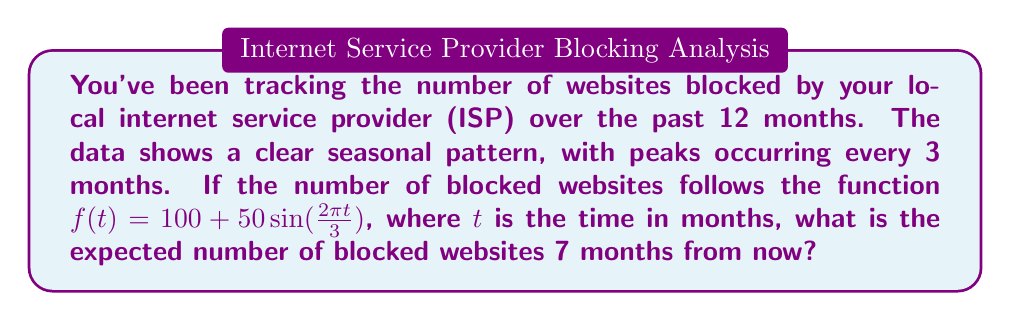Solve this math problem. To solve this problem, we need to follow these steps:

1. Understand the given function:
   $f(t) = 100 + 50\sin(\frac{2\pi t}{3})$
   
   Here, 100 is the baseline number of blocked websites, and the sine function represents the seasonal fluctuation.

2. Determine the value of $t$:
   We're asked about 7 months from now, so $t = 7$.

3. Substitute $t = 7$ into the function:
   $f(7) = 100 + 50\sin(\frac{2\pi \cdot 7}{3})$

4. Simplify the argument of the sine function:
   $\frac{2\pi \cdot 7}{3} = \frac{14\pi}{3}$

5. Calculate the sine of $\frac{14\pi}{3}$:
   $\sin(\frac{14\pi}{3}) = \sin(\frac{4\pi}{3} + \frac{10\pi}{3}) = \sin(\frac{4\pi}{3}) = -\frac{\sqrt{3}}{2}$

6. Substitute this value back into the function:
   $f(7) = 100 + 50 \cdot (-\frac{\sqrt{3}}{2})$

7. Simplify:
   $f(7) = 100 - 25\sqrt{3} \approx 56.7$

Therefore, the expected number of blocked websites 7 months from now is approximately 56.7, or 57 when rounded to the nearest whole number.
Answer: $57$ blocked websites (rounded to the nearest whole number) 